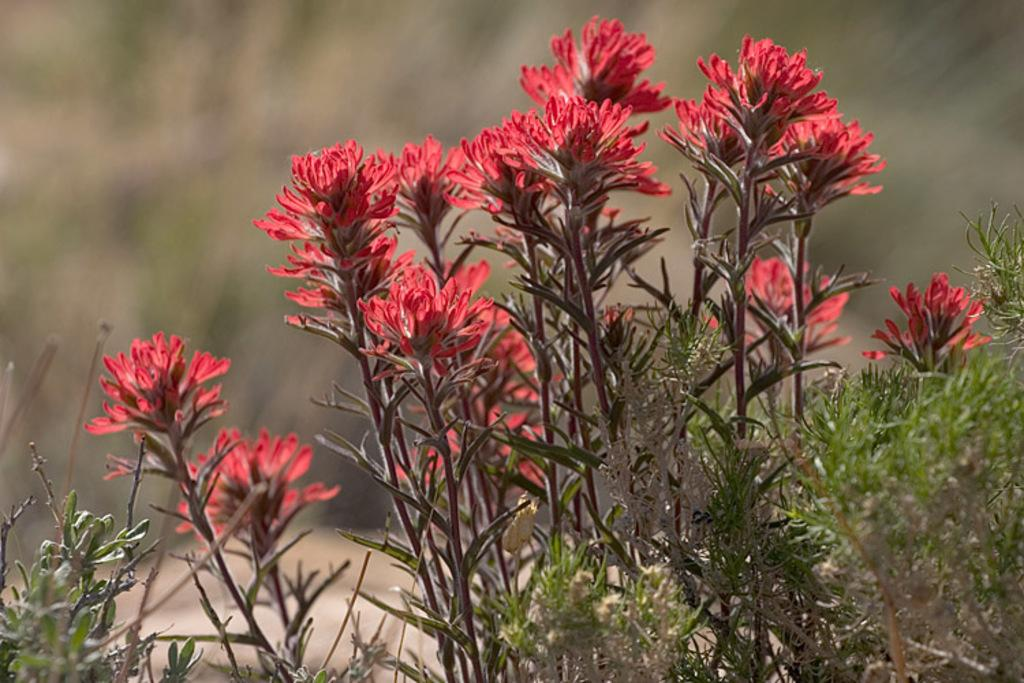What type of plants are in the image? There are red color flower plants in the image. Can you describe the background of the image? The background of the image is blurry. How many kittens are playing in the sink in the image? There are no kittens or sinks present in the image; it features red color flower plants with a blurry background. 